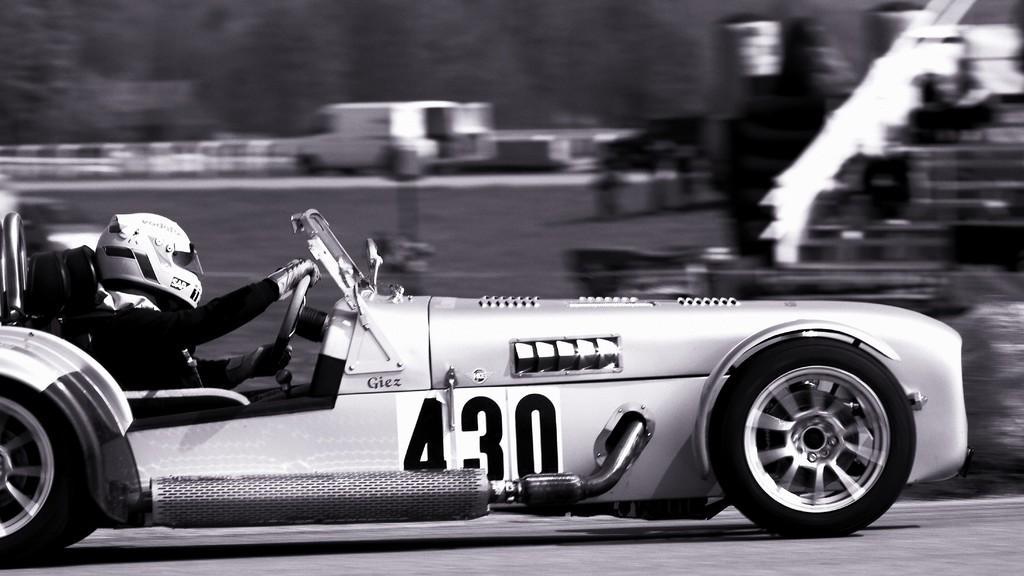Could you give a brief overview of what you see in this image? In this image I can see a person riding on car and person wearing a helmet. 